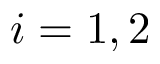<formula> <loc_0><loc_0><loc_500><loc_500>i = 1 , 2</formula> 